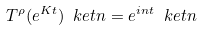Convert formula to latex. <formula><loc_0><loc_0><loc_500><loc_500>T ^ { \rho } ( e ^ { K t } ) \ k e t { n } = e ^ { i n t } \ k e t { n }</formula> 